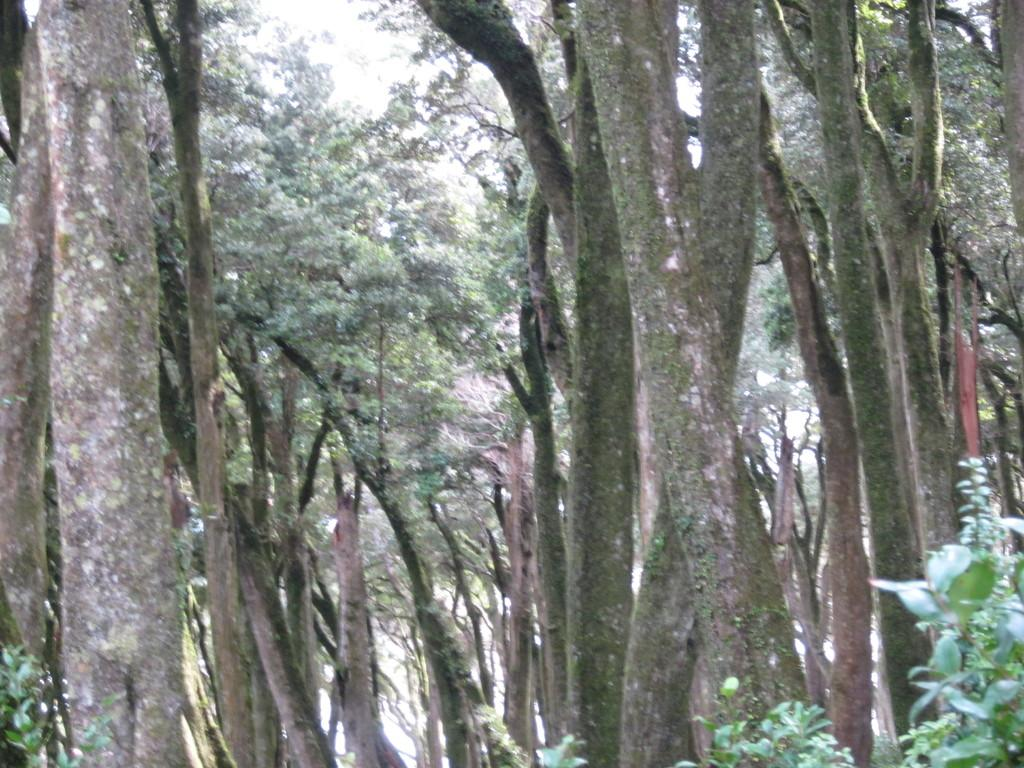What type of vegetation can be seen in the background of the image? There are trees in the background of the image. What else is visible in the background of the image? The sky is visible in the background of the image. How many fingers can be seen in the image? There is no reference to fingers in the image, so it is not possible to determine how many fingers might be present. 